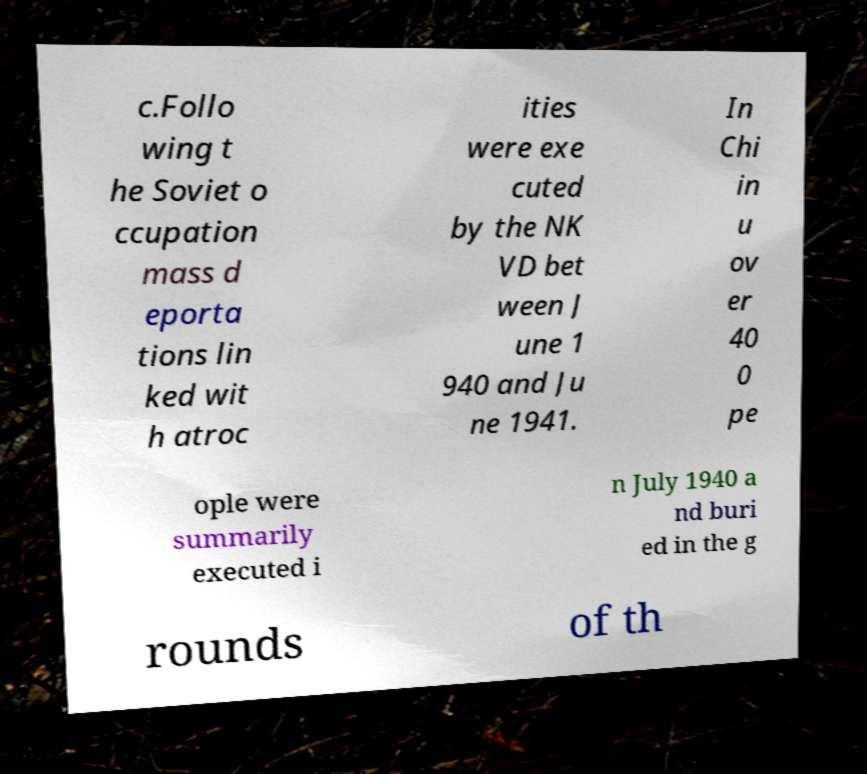Could you extract and type out the text from this image? c.Follo wing t he Soviet o ccupation mass d eporta tions lin ked wit h atroc ities were exe cuted by the NK VD bet ween J une 1 940 and Ju ne 1941. In Chi in u ov er 40 0 pe ople were summarily executed i n July 1940 a nd buri ed in the g rounds of th 